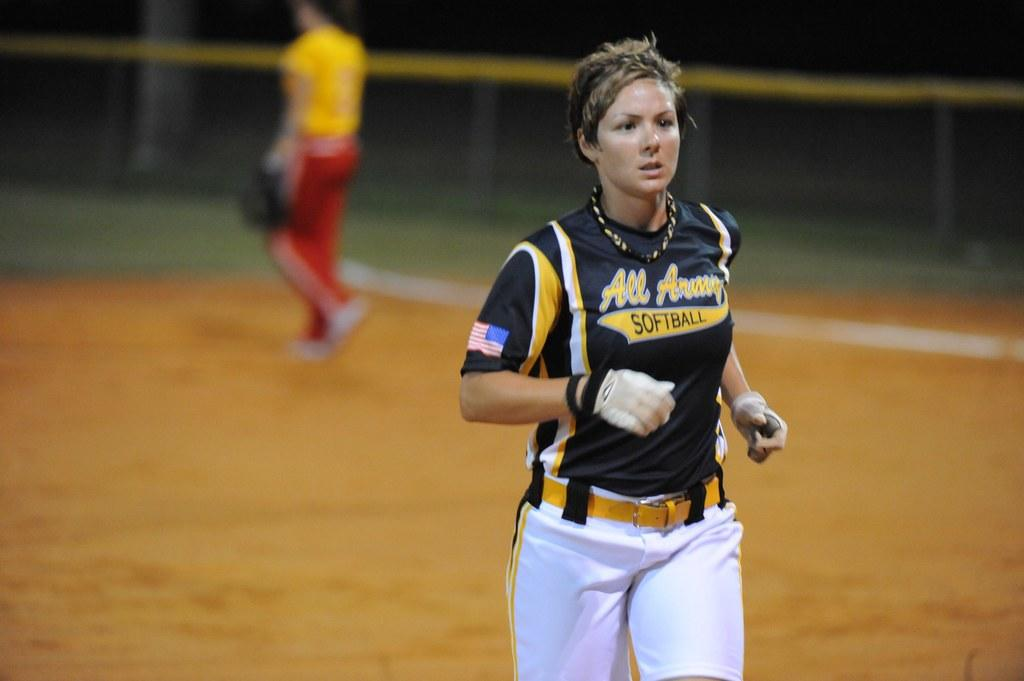<image>
Create a compact narrative representing the image presented. A female player with the word softball on her black jersey 